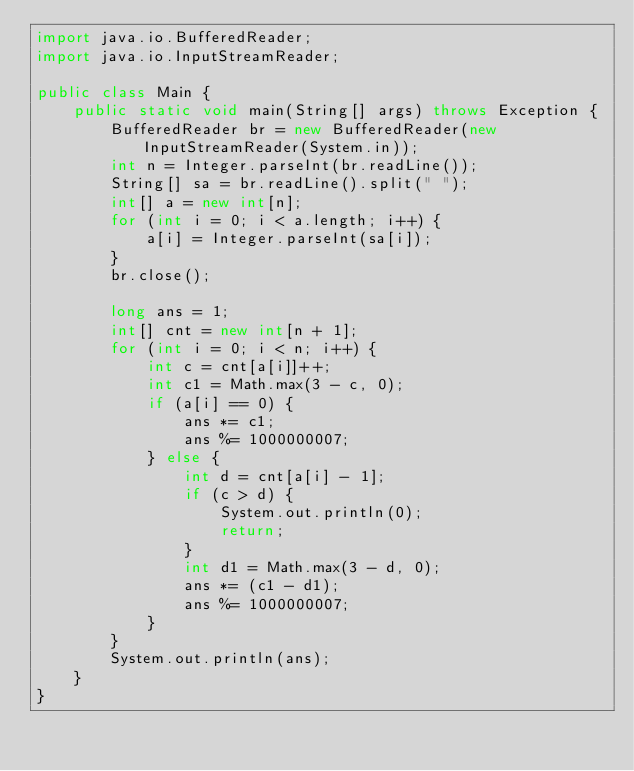Convert code to text. <code><loc_0><loc_0><loc_500><loc_500><_Java_>import java.io.BufferedReader;
import java.io.InputStreamReader;

public class Main {
	public static void main(String[] args) throws Exception {
		BufferedReader br = new BufferedReader(new InputStreamReader(System.in));
		int n = Integer.parseInt(br.readLine());
		String[] sa = br.readLine().split(" ");
		int[] a = new int[n];
		for (int i = 0; i < a.length; i++) {
			a[i] = Integer.parseInt(sa[i]);
		}
		br.close();

		long ans = 1;
		int[] cnt = new int[n + 1];
		for (int i = 0; i < n; i++) {
			int c = cnt[a[i]]++;
			int c1 = Math.max(3 - c, 0);
			if (a[i] == 0) {
				ans *= c1;
				ans %= 1000000007;
			} else {
				int d = cnt[a[i] - 1];
				if (c > d) {
					System.out.println(0);
					return;
				}
				int d1 = Math.max(3 - d, 0);
				ans *= (c1 - d1);
				ans %= 1000000007;
			}
		}
		System.out.println(ans);
	}
}
</code> 